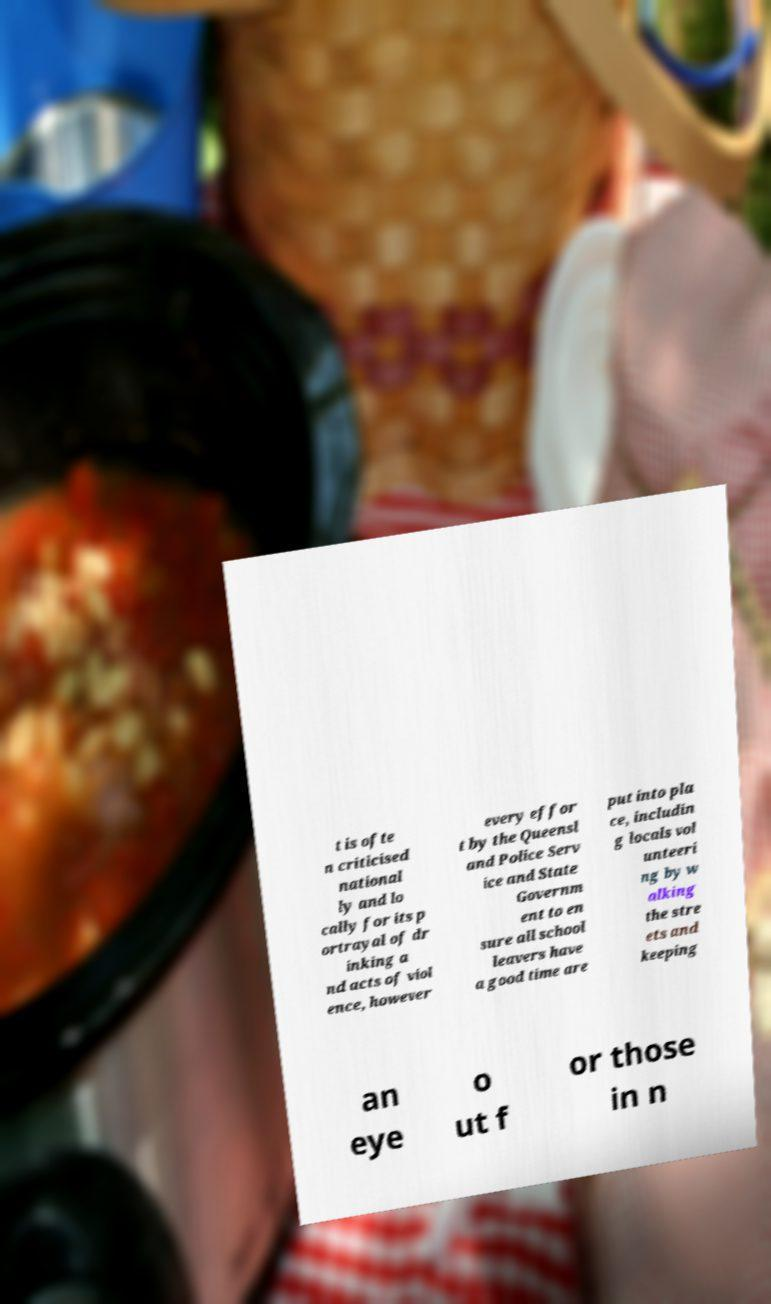What messages or text are displayed in this image? I need them in a readable, typed format. t is ofte n criticised national ly and lo cally for its p ortrayal of dr inking a nd acts of viol ence, however every effor t by the Queensl and Police Serv ice and State Governm ent to en sure all school leavers have a good time are put into pla ce, includin g locals vol unteeri ng by w alking the stre ets and keeping an eye o ut f or those in n 